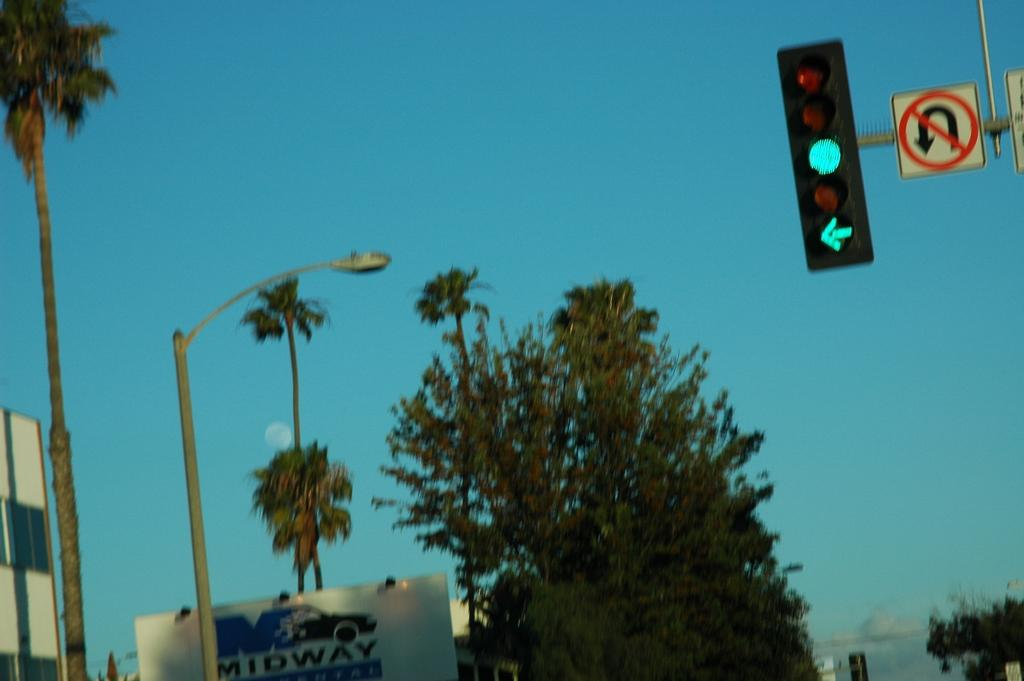<image>
Summarize the visual content of the image. a green traffic light with a sign saying not to do u-turns 